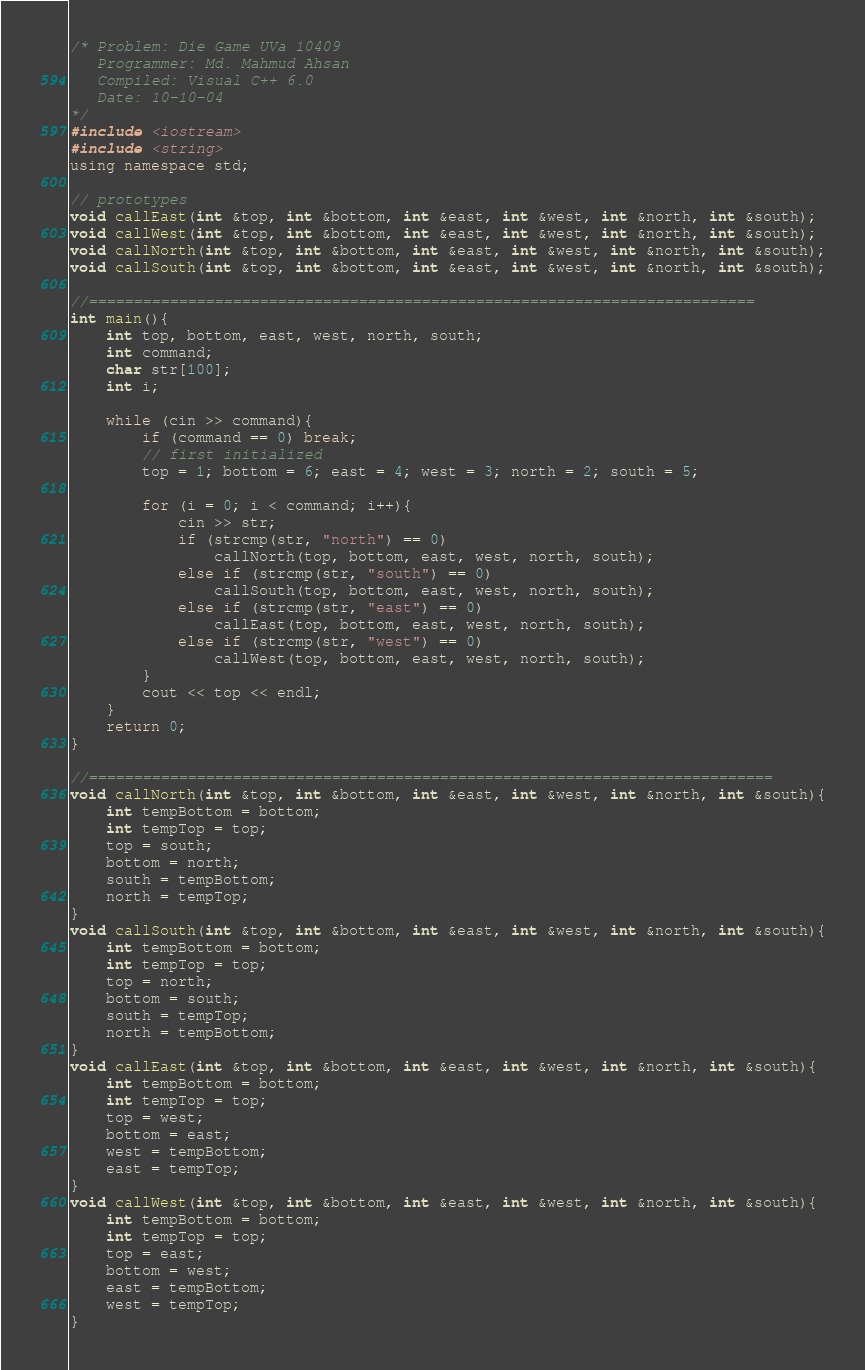<code> <loc_0><loc_0><loc_500><loc_500><_C++_>/* Problem: Die Game UVa 10409
   Programmer: Md. Mahmud Ahsan
   Compiled: Visual C++ 6.0
   Date: 10-10-04
*/
#include <iostream>
#include <string>
using namespace std;

// prototypes
void callEast(int &top, int &bottom, int &east, int &west, int &north, int &south);
void callWest(int &top, int &bottom, int &east, int &west, int &north, int &south);
void callNorth(int &top, int &bottom, int &east, int &west, int &north, int &south);
void callSouth(int &top, int &bottom, int &east, int &west, int &north, int &south);

//==========================================================================
int main(){
	int top, bottom, east, west, north, south;
	int command;
	char str[100];
	int i;

	while (cin >> command){
		if (command == 0) break;
		// first initialized
		top = 1; bottom = 6; east = 4; west = 3; north = 2; south = 5;

		for (i = 0; i < command; i++){
			cin >> str;
			if (strcmp(str, "north") == 0)
				callNorth(top, bottom, east, west, north, south);
			else if (strcmp(str, "south") == 0)
				callSouth(top, bottom, east, west, north, south);
			else if (strcmp(str, "east") == 0)
				callEast(top, bottom, east, west, north, south);
			else if (strcmp(str, "west") == 0)
				callWest(top, bottom, east, west, north, south);
		}
		cout << top << endl;
	}
	return 0;
}

//============================================================================
void callNorth(int &top, int &bottom, int &east, int &west, int &north, int &south){
	int tempBottom = bottom;
	int tempTop = top;
	top = south;
	bottom = north;
	south = tempBottom;
	north = tempTop;
}
void callSouth(int &top, int &bottom, int &east, int &west, int &north, int &south){
	int tempBottom = bottom;
	int tempTop = top;
	top = north;
	bottom = south;
	south = tempTop;
	north = tempBottom;
}
void callEast(int &top, int &bottom, int &east, int &west, int &north, int &south){
	int tempBottom = bottom;
	int tempTop = top;
	top = west;
	bottom = east;
	west = tempBottom;
	east = tempTop;
}
void callWest(int &top, int &bottom, int &east, int &west, int &north, int &south){
	int tempBottom = bottom;
	int tempTop = top;
	top = east;
	bottom = west;
	east = tempBottom;
	west = tempTop;
}</code> 